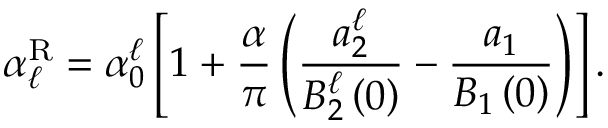<formula> <loc_0><loc_0><loc_500><loc_500>\alpha _ { \ell } ^ { R } = \alpha _ { 0 } ^ { \ell } \left [ 1 + \frac { \alpha } { \pi } \left ( \frac { a _ { 2 } ^ { \ell } } { B _ { 2 } ^ { \ell } \left ( 0 \right ) } - \frac { a _ { 1 } } { B _ { 1 } \left ( 0 \right ) } \right ) \right ] .</formula> 